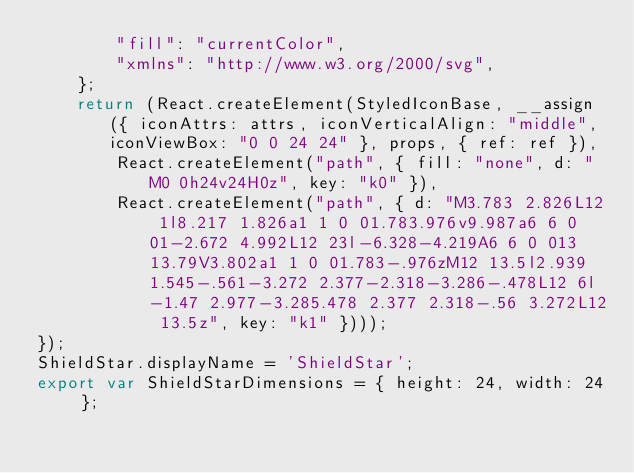<code> <loc_0><loc_0><loc_500><loc_500><_JavaScript_>        "fill": "currentColor",
        "xmlns": "http://www.w3.org/2000/svg",
    };
    return (React.createElement(StyledIconBase, __assign({ iconAttrs: attrs, iconVerticalAlign: "middle", iconViewBox: "0 0 24 24" }, props, { ref: ref }),
        React.createElement("path", { fill: "none", d: "M0 0h24v24H0z", key: "k0" }),
        React.createElement("path", { d: "M3.783 2.826L12 1l8.217 1.826a1 1 0 01.783.976v9.987a6 6 0 01-2.672 4.992L12 23l-6.328-4.219A6 6 0 013 13.79V3.802a1 1 0 01.783-.976zM12 13.5l2.939 1.545-.561-3.272 2.377-2.318-3.286-.478L12 6l-1.47 2.977-3.285.478 2.377 2.318-.56 3.272L12 13.5z", key: "k1" })));
});
ShieldStar.displayName = 'ShieldStar';
export var ShieldStarDimensions = { height: 24, width: 24 };
</code> 